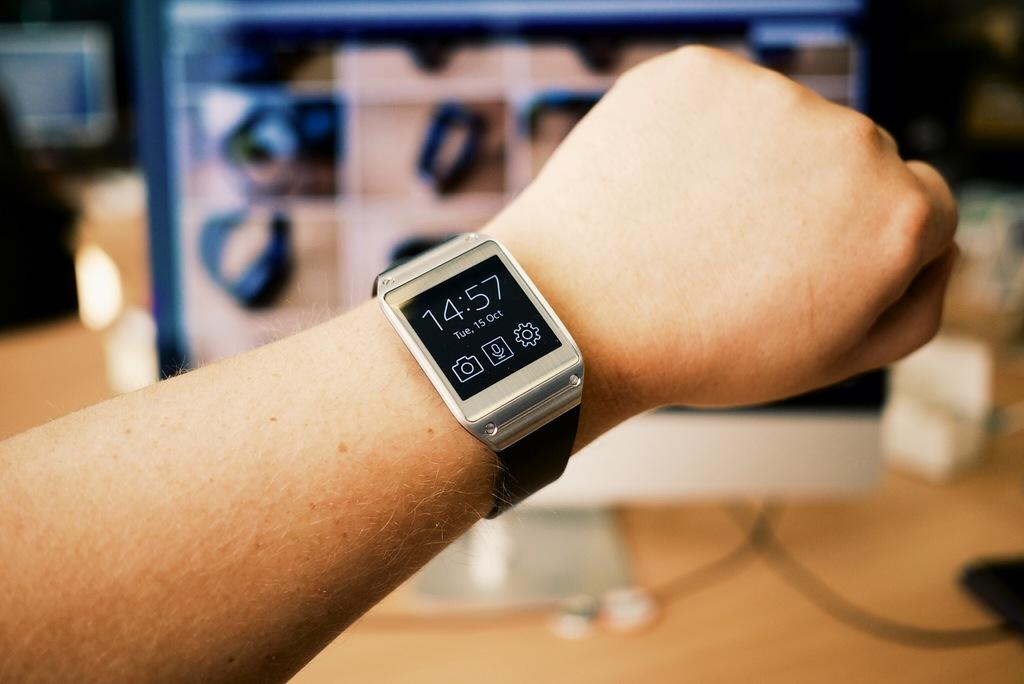<image>
Give a short and clear explanation of the subsequent image. A hand is holding up a watch showing that it's 14:57 on October 15th. 